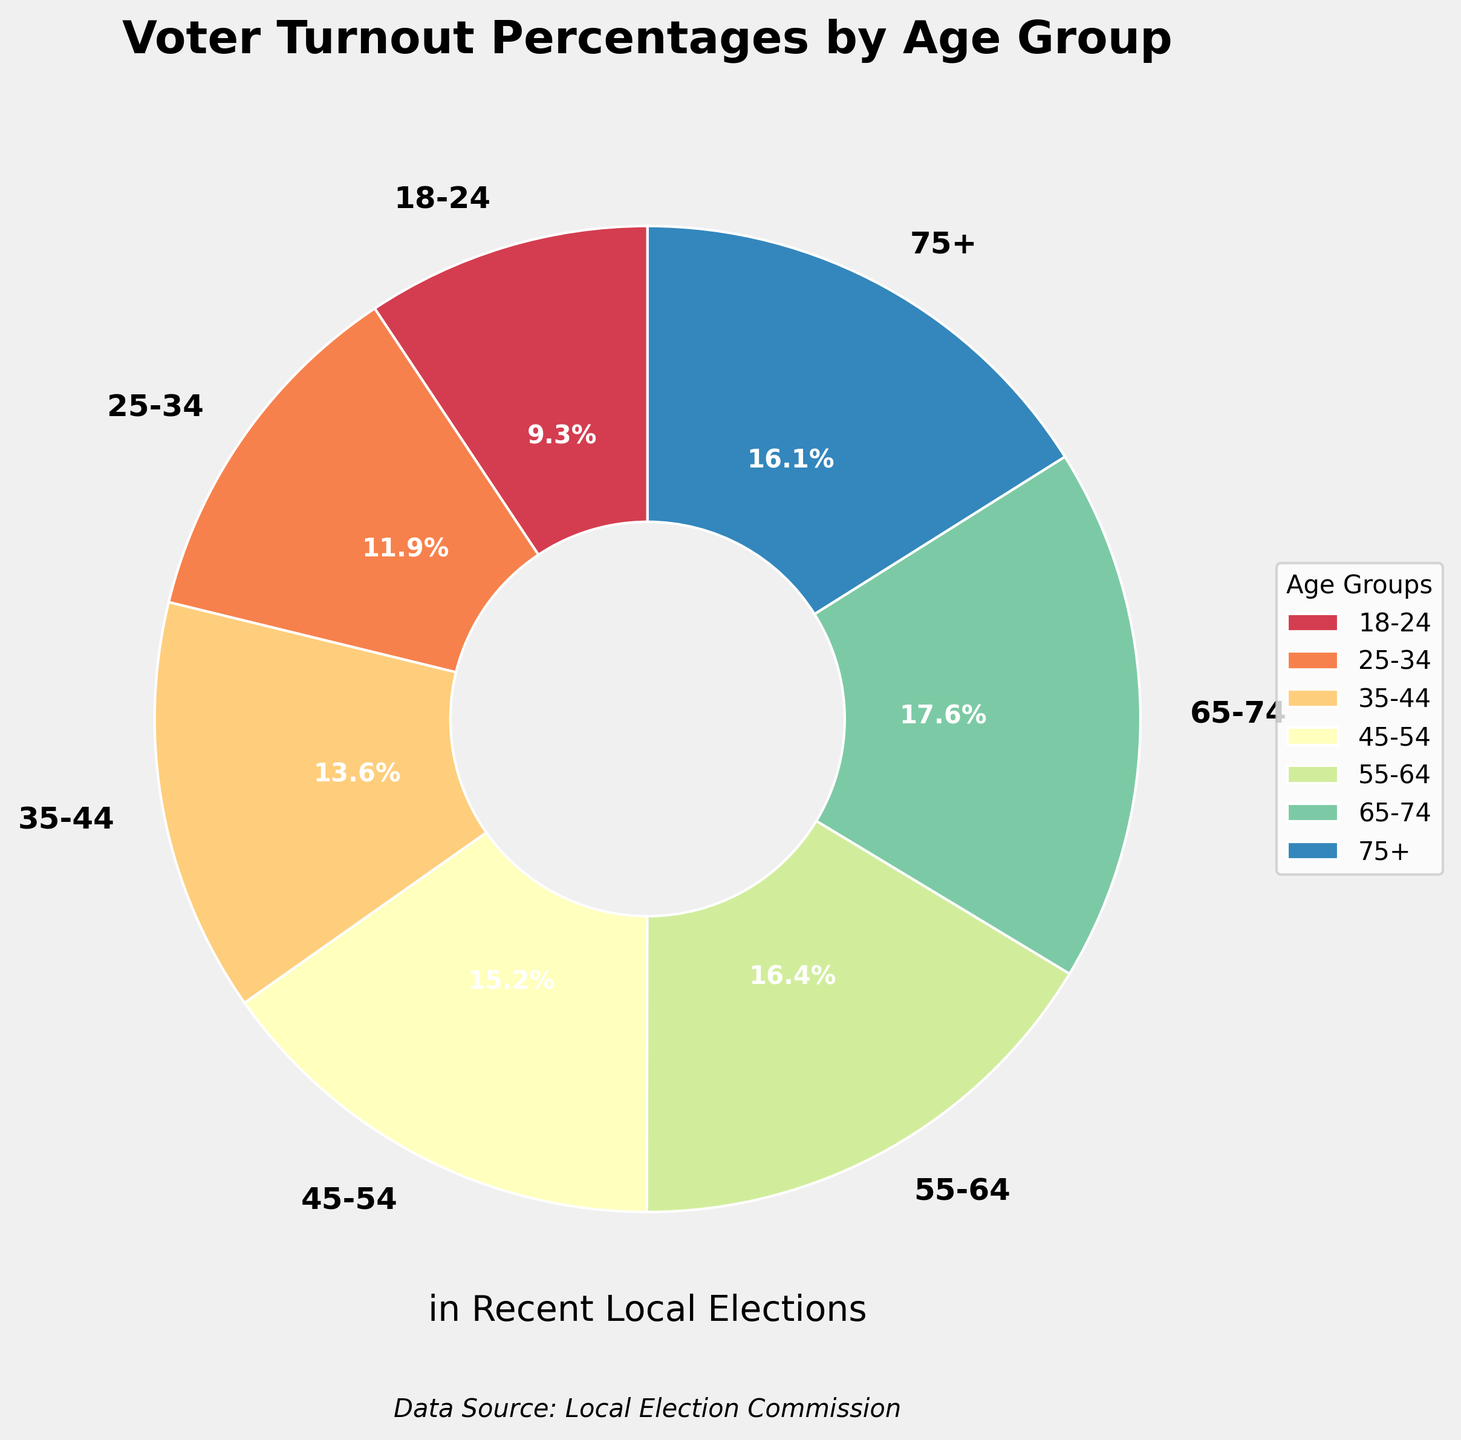What's the highest voter turnout percentage among the age groups? By examining the chart, the highest percentage can be seen. The 65-74 age group has the highest voter turnout percentage at 79.6%.
Answer: 79.6% Which age group has the lowest voter turnout percentage? The lowest percentage is visible in the chart as 18-24 age group with 42.3%.
Answer: 18-24 Compare the voter turnout between the 25-34 and 35-44 age groups. Which age group has a higher percentage? The chart shows that the 35-44 age group has a voter turnout percentage of 61.5%, whereas the 25-34 age group's turnout is 53.7%. Thus, the 35-44 group has a higher turnout percentage.
Answer: 35-44 What is the combined voter turnout percentage of the age groups 55-64 and 65-74? By adding the percentages of these two age groups (74.2% and 79.6%), the combined turnout rate is calculated as 74.2 + 79.6 = 153.8%.
Answer: 153.8% How much more is the voter turnout percentage of the 45-54 age group compared to the 18-24 age group? Subtract the 18-24 age group's percentage from the 45-54 age group's: 68.9% - 42.3% = 26.6%.
Answer: 26.6% What is the average voter turnout percentage across all age groups? Sum all age group percentages and divide by the number of age groups: (42.3 + 53.7 + 61.5 + 68.9 + 74.2 + 79.6 + 72.8) / 7 ≈ 64.71%.
Answer: 64.71% Between the 55-64 and 75+ age groups, which group has a lower voter turnout percentage? The 75+ age group has a voter turnout percentage of 72.8%, while the 55-64 group has 74.2%. Therefore, the 75+ age group has a lower percentage.
Answer: 75+ Identify the age groups with percentages in the 70s range. The age groups with percentages in the 70s are 55-64 (74.2%), 65-74 (79.6%), and 75+ (72.8%).
Answer: 55-64, 65-74, 75+ Which age group has a voter turnout percentage closest to the overall average? The overall average voter turnout percentage is approximately 64.71%. The 65-74 age group has a percentage of 79.6%, and the 55-64 age group has 74.2%, respectively, which are higher. By comparing each, the 45-54 age group with 68.9% is the closest.
Answer: 45-54 